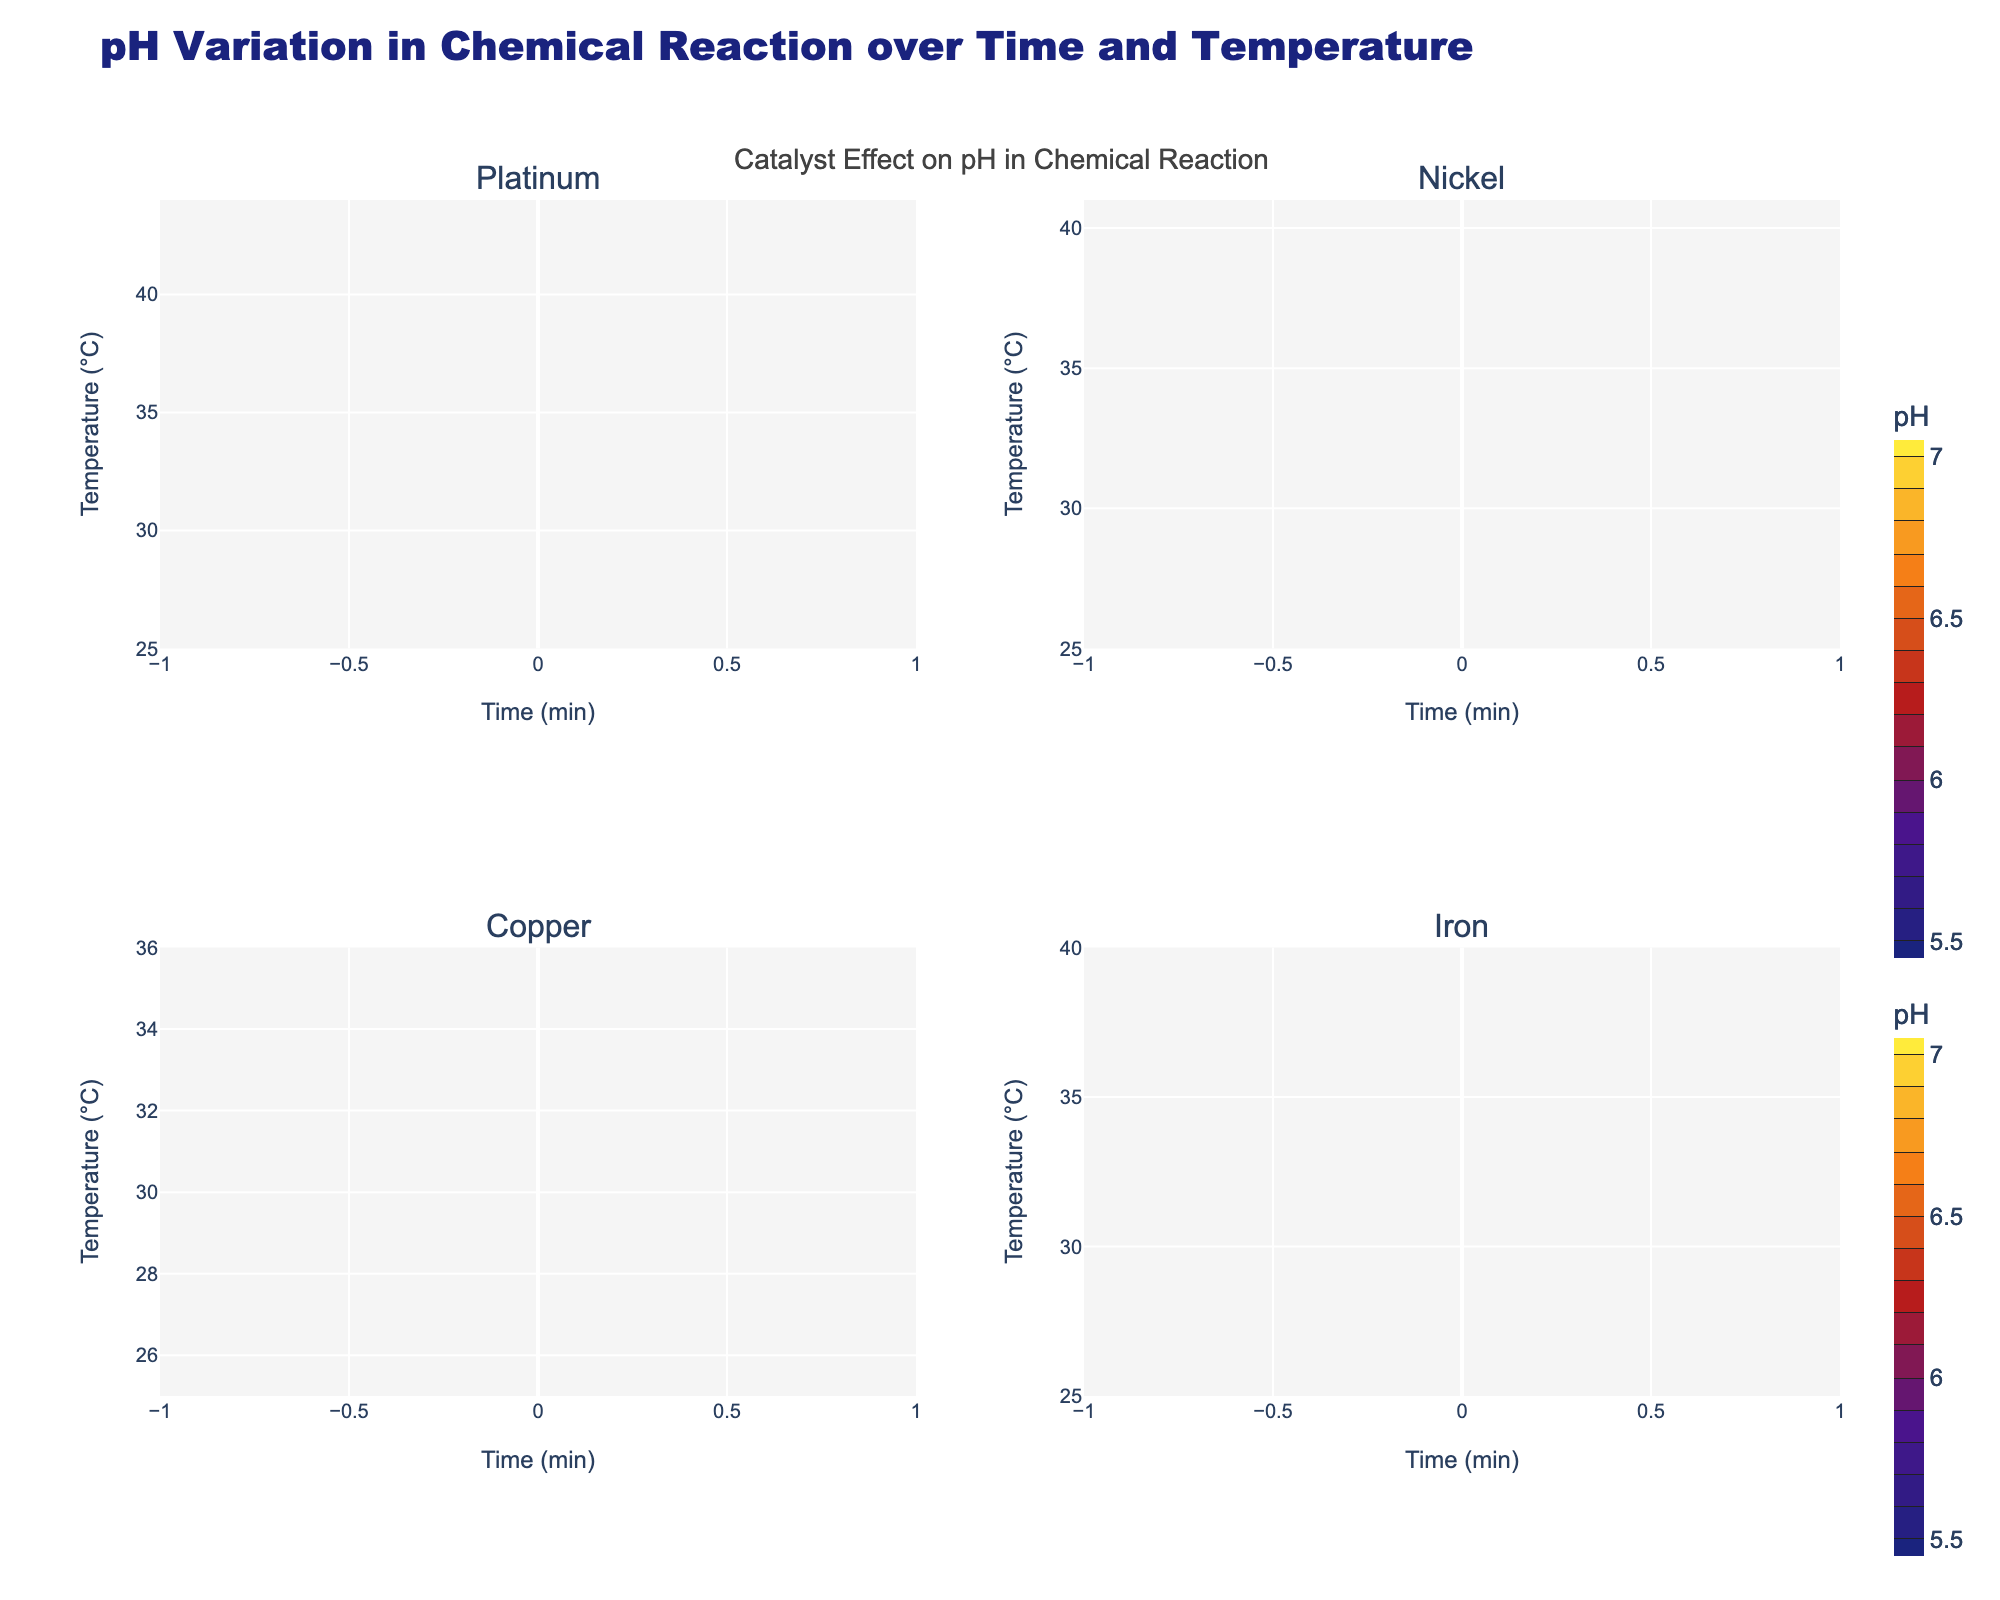What's the title of the figure? The title of the figure is prominently displayed at the top and reads "pH Variation in Chemical Reaction over Time and Temperature."
Answer: pH Variation in Chemical Reaction over Time and Temperature What are the titles of the individual subplots? Each subplot is labeled with the name of the catalyst it represents. The titles of the subplots are: "Platinum," "Nickel," "Copper," and "Iron."
Answer: Platinum, Nickel, Copper, Iron How does the pH value change over time for the catalyst Platinum? By observing the contour in the Platinum subplot, the pH value generally decreases as time increases. The pH starts at 7.0 and decreases to 5.6 at 60 minutes.
Answer: Decreases Which catalyst has the highest pH at 60 minutes? In the subplot for each catalyst, examine the pH value at the 60-minute mark. Platinum: 5.6, Nickel: 5.9, Copper: 6.0, Iron: 6.0. Both Copper and Iron maintain the highest pH of 6.0 at 60 minutes.
Answer: Copper and Iron Compare the temperature at 30 minutes for all catalysts. Which catalyst exhibits the highest temperature? At 30 minutes, we compare the temperatures in the subplots. Platinum: 33°C, Nickel: 32°C, Copper: 30°C, Iron: 33°C. Both Platinum and Iron exhibit the highest temperature at this time point.
Answer: Platinum and Iron Which catalyst shows the steepest decrease in pH over time? To determine the steepest decrease, we observe the contour lines' density in each subplot. The catalyst with the closest contour lines indicates the steepest gradient. Platinum shows the closest lines, indicating the steepest pH decrease.
Answer: Platinum What is the temperature range for the Iron catalyst? By looking at the y-axis of the Iron subplot, the temperature ranges from 25°C to 40°C.
Answer: 25°C to 40°C At what time does the Nickel catalyst first reach a temperature of 35°C? In the Nickel subplot, follow the contour line to see when it intersects with the 35°C mark on the y-axis. It occurs at 40 minutes.
Answer: 40 minutes Evaluate the catalysts and determine which one maintains the most stable pH level over time. The contour lines' spacing in each subplot indicates pH stability. Wider spacing means less change. Copper has the widest spacing, indicating it maintains the most stable pH over time.
Answer: Copper 